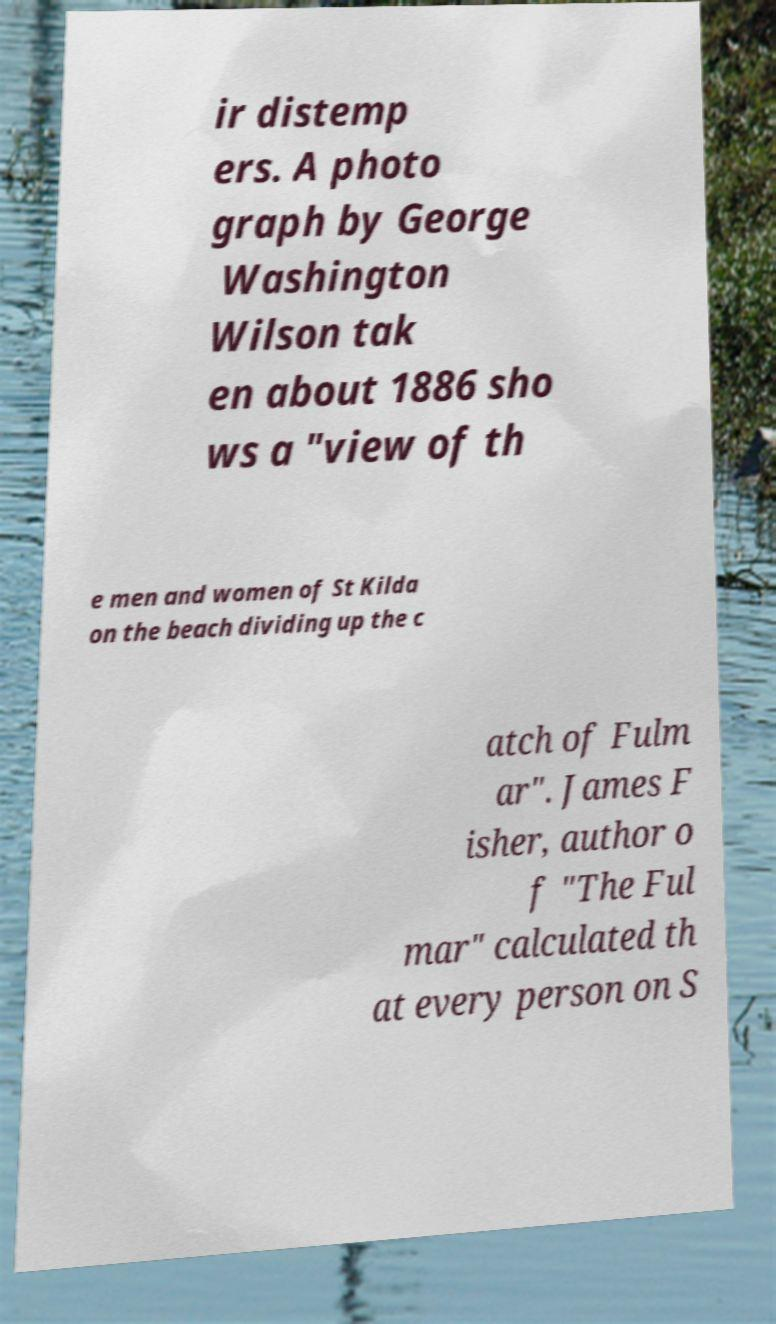What messages or text are displayed in this image? I need them in a readable, typed format. ir distemp ers. A photo graph by George Washington Wilson tak en about 1886 sho ws a "view of th e men and women of St Kilda on the beach dividing up the c atch of Fulm ar". James F isher, author o f "The Ful mar" calculated th at every person on S 